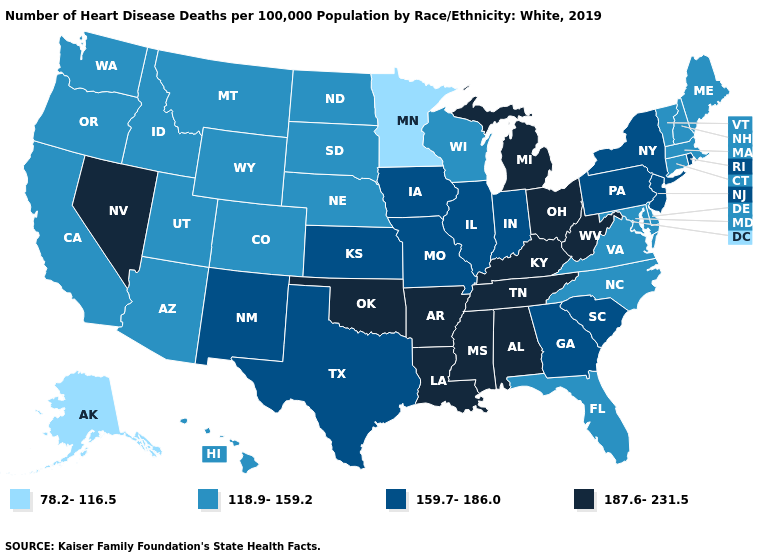Name the states that have a value in the range 118.9-159.2?
Answer briefly. Arizona, California, Colorado, Connecticut, Delaware, Florida, Hawaii, Idaho, Maine, Maryland, Massachusetts, Montana, Nebraska, New Hampshire, North Carolina, North Dakota, Oregon, South Dakota, Utah, Vermont, Virginia, Washington, Wisconsin, Wyoming. Among the states that border Montana , which have the highest value?
Be succinct. Idaho, North Dakota, South Dakota, Wyoming. Name the states that have a value in the range 159.7-186.0?
Answer briefly. Georgia, Illinois, Indiana, Iowa, Kansas, Missouri, New Jersey, New Mexico, New York, Pennsylvania, Rhode Island, South Carolina, Texas. Name the states that have a value in the range 118.9-159.2?
Answer briefly. Arizona, California, Colorado, Connecticut, Delaware, Florida, Hawaii, Idaho, Maine, Maryland, Massachusetts, Montana, Nebraska, New Hampshire, North Carolina, North Dakota, Oregon, South Dakota, Utah, Vermont, Virginia, Washington, Wisconsin, Wyoming. What is the value of Iowa?
Short answer required. 159.7-186.0. What is the lowest value in states that border Delaware?
Give a very brief answer. 118.9-159.2. Does Maryland have the same value as Idaho?
Short answer required. Yes. Which states have the lowest value in the USA?
Write a very short answer. Alaska, Minnesota. Among the states that border Pennsylvania , which have the highest value?
Answer briefly. Ohio, West Virginia. Name the states that have a value in the range 78.2-116.5?
Keep it brief. Alaska, Minnesota. What is the value of Alabama?
Keep it brief. 187.6-231.5. Name the states that have a value in the range 187.6-231.5?
Be succinct. Alabama, Arkansas, Kentucky, Louisiana, Michigan, Mississippi, Nevada, Ohio, Oklahoma, Tennessee, West Virginia. Name the states that have a value in the range 118.9-159.2?
Give a very brief answer. Arizona, California, Colorado, Connecticut, Delaware, Florida, Hawaii, Idaho, Maine, Maryland, Massachusetts, Montana, Nebraska, New Hampshire, North Carolina, North Dakota, Oregon, South Dakota, Utah, Vermont, Virginia, Washington, Wisconsin, Wyoming. What is the value of Wyoming?
Write a very short answer. 118.9-159.2. Among the states that border New Jersey , does New York have the lowest value?
Short answer required. No. 